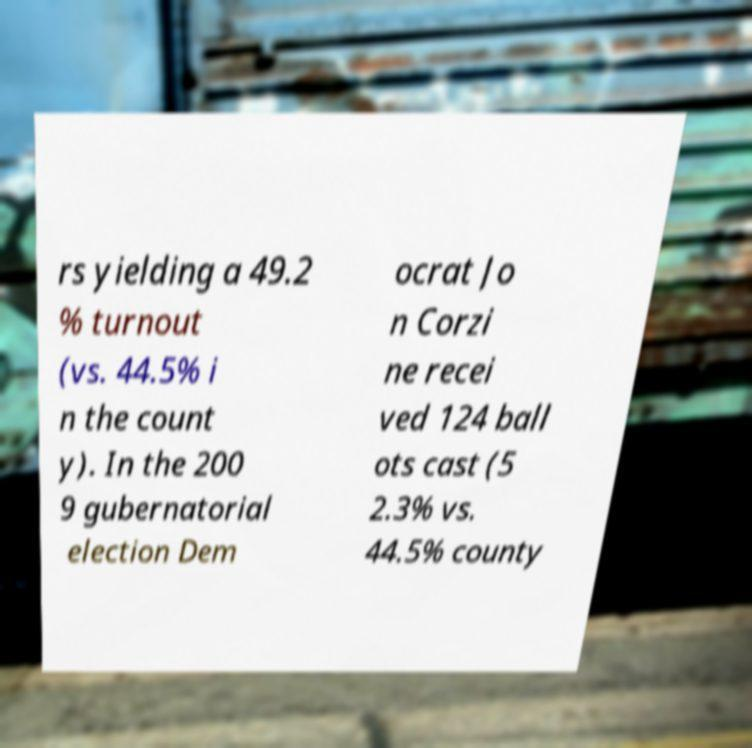Can you read and provide the text displayed in the image?This photo seems to have some interesting text. Can you extract and type it out for me? rs yielding a 49.2 % turnout (vs. 44.5% i n the count y). In the 200 9 gubernatorial election Dem ocrat Jo n Corzi ne recei ved 124 ball ots cast (5 2.3% vs. 44.5% county 